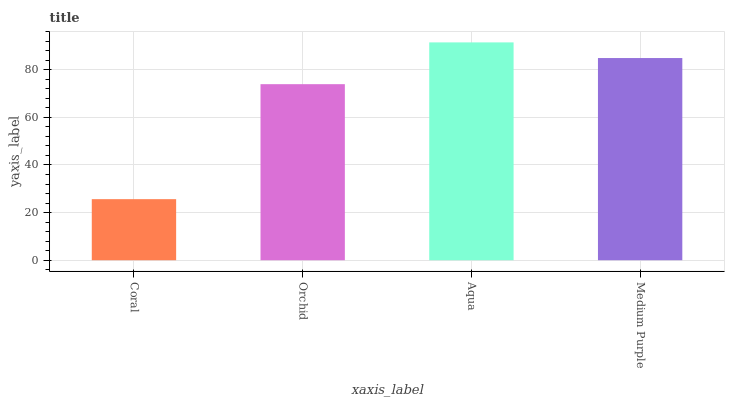Is Orchid the minimum?
Answer yes or no. No. Is Orchid the maximum?
Answer yes or no. No. Is Orchid greater than Coral?
Answer yes or no. Yes. Is Coral less than Orchid?
Answer yes or no. Yes. Is Coral greater than Orchid?
Answer yes or no. No. Is Orchid less than Coral?
Answer yes or no. No. Is Medium Purple the high median?
Answer yes or no. Yes. Is Orchid the low median?
Answer yes or no. Yes. Is Orchid the high median?
Answer yes or no. No. Is Medium Purple the low median?
Answer yes or no. No. 